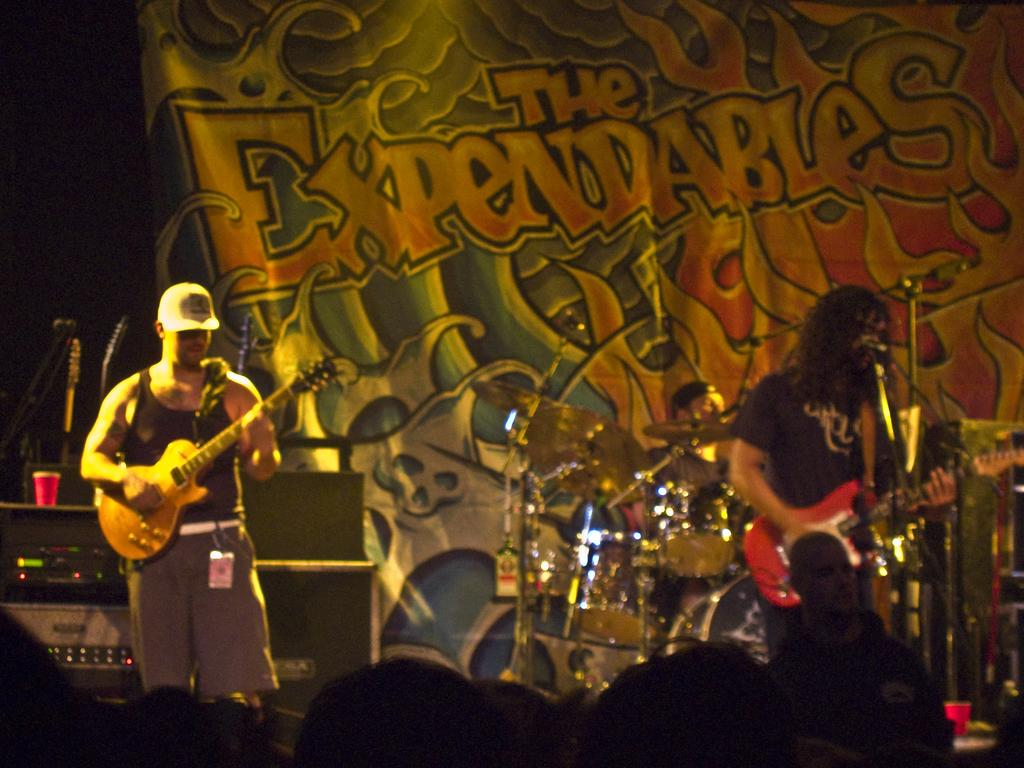How many people are playing guitar in the image? There are two men in the image who are playing guitar. What are the men doing in the image? The men are playing guitar. Are there any other people in the image besides the men playing guitar? Yes, there are people in the image who appear to be watching the men play guitar. What channel is the guitar performance being broadcasted on in the image? There is no indication in the image that the guitar performance is being broadcasted on a channel. 